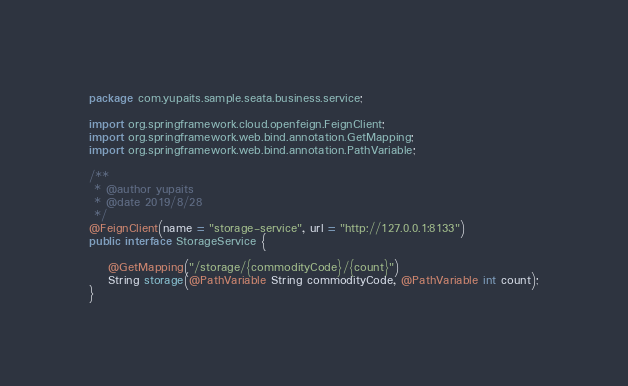<code> <loc_0><loc_0><loc_500><loc_500><_Java_>package com.yupaits.sample.seata.business.service;

import org.springframework.cloud.openfeign.FeignClient;
import org.springframework.web.bind.annotation.GetMapping;
import org.springframework.web.bind.annotation.PathVariable;

/**
 * @author yupaits
 * @date 2019/8/28
 */
@FeignClient(name = "storage-service", url = "http://127.0.0.1:8133")
public interface StorageService {

    @GetMapping("/storage/{commodityCode}/{count}")
    String storage(@PathVariable String commodityCode, @PathVariable int count);
}
</code> 